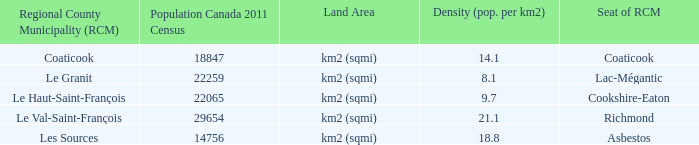What is the land area for the RCM that has a population of 18847? Km2 (sqmi). 